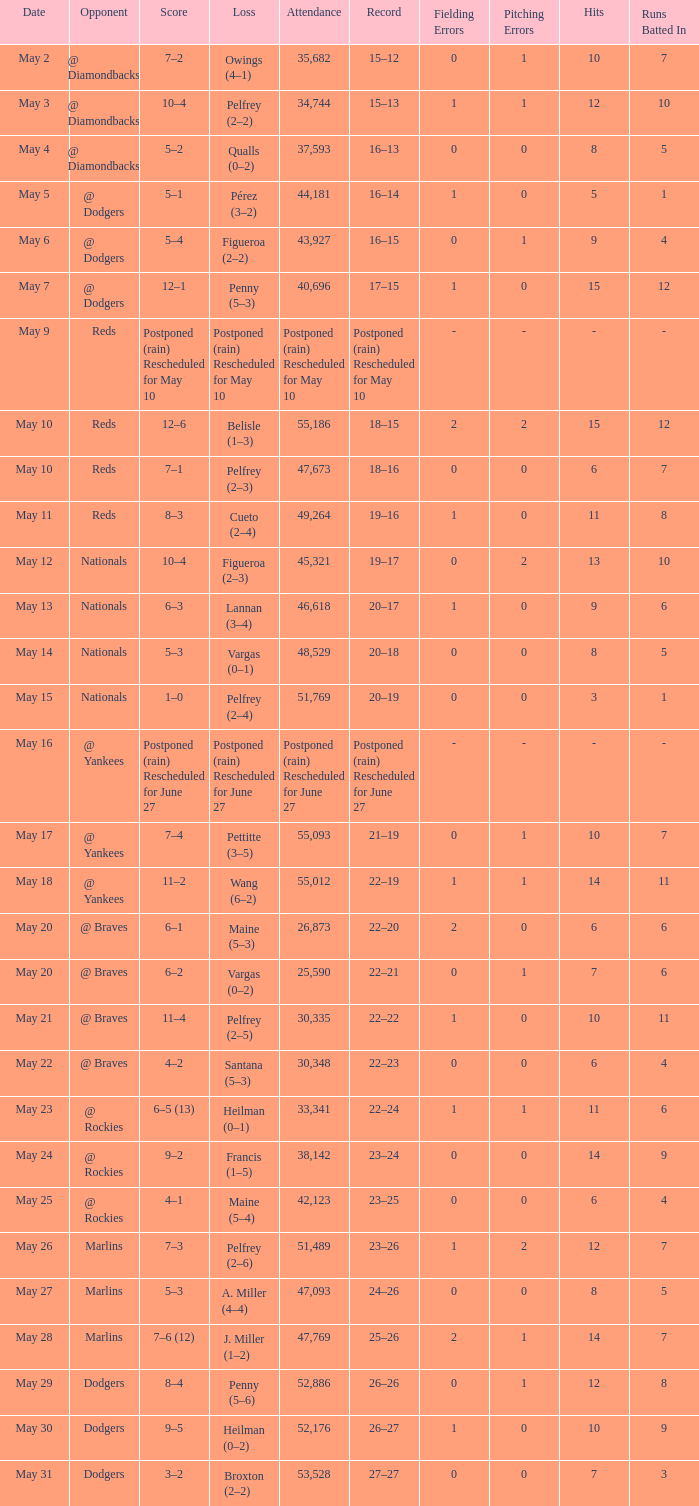Score of postponed (rain) rescheduled for June 27 had what loss? Postponed (rain) Rescheduled for June 27. 